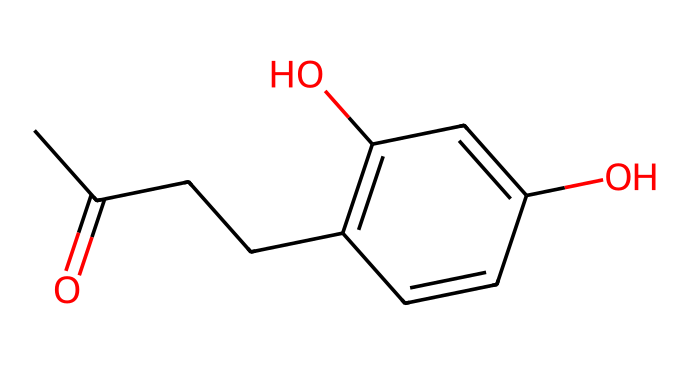How many carbon atoms are in raspberry ketone? By looking at the SMILES representation, count the instances of the letter "C," which represents carbon atoms in the structure. There are nine "C" characters in total, indicating there are nine carbon atoms in raspberry ketone.
Answer: nine What is the functional group present in raspberry ketone? The SMILES notation includes a carbonyl group (C=O) indicated by the "=O" that is connected to a carbon atom "C." This defines it as a ketone.
Answer: ketone How many hydroxyl (–OH) groups are in raspberry ketone? The SMILES representation shows two "O" characters that are connected to hydrogen atoms. The “O” in the structure followed by hydrogen (implied) indicates hydroxyl groups. Count the number of "O" connections; there are two.
Answer: two What type of structural feature indicates aromaticity in raspberry ketone? In the chemical structure, the presence of "C=C" bonds in a cyclic arrangement, like in the ring (C1=C(C=C(C=C1)), indicates that this part of the molecule is aromatic due to alternating double bonds.
Answer: aromatic ring How many double bonds are present in raspberry ketone? To find double bonds, check for every instance of "=" in the SMILES. There are two "=" symbols in the structure, which indicates the presence of two double bonds.
Answer: two What is the total number of oxygen atoms within the raspberry ketone molecule? Inspect the SMILES representation for "O" characters that indicate the presence of oxygen atoms. There are two occurrences of "O," indicating there are two oxygen atoms.
Answer: two Which part of the molecule indicates that raspberry ketone is a ketone rather than an aldehyde? In the molecule, the carbonyl (C=O) is connected to two carbon atoms (making it a ketone), unlike an aldehyde that has at least one hydrogen attached to the carbonyl carbon. The structure shows the carbonyl is flanked by carbon chains, confirming it is a ketone.
Answer: carbonyl group connected to carbons 